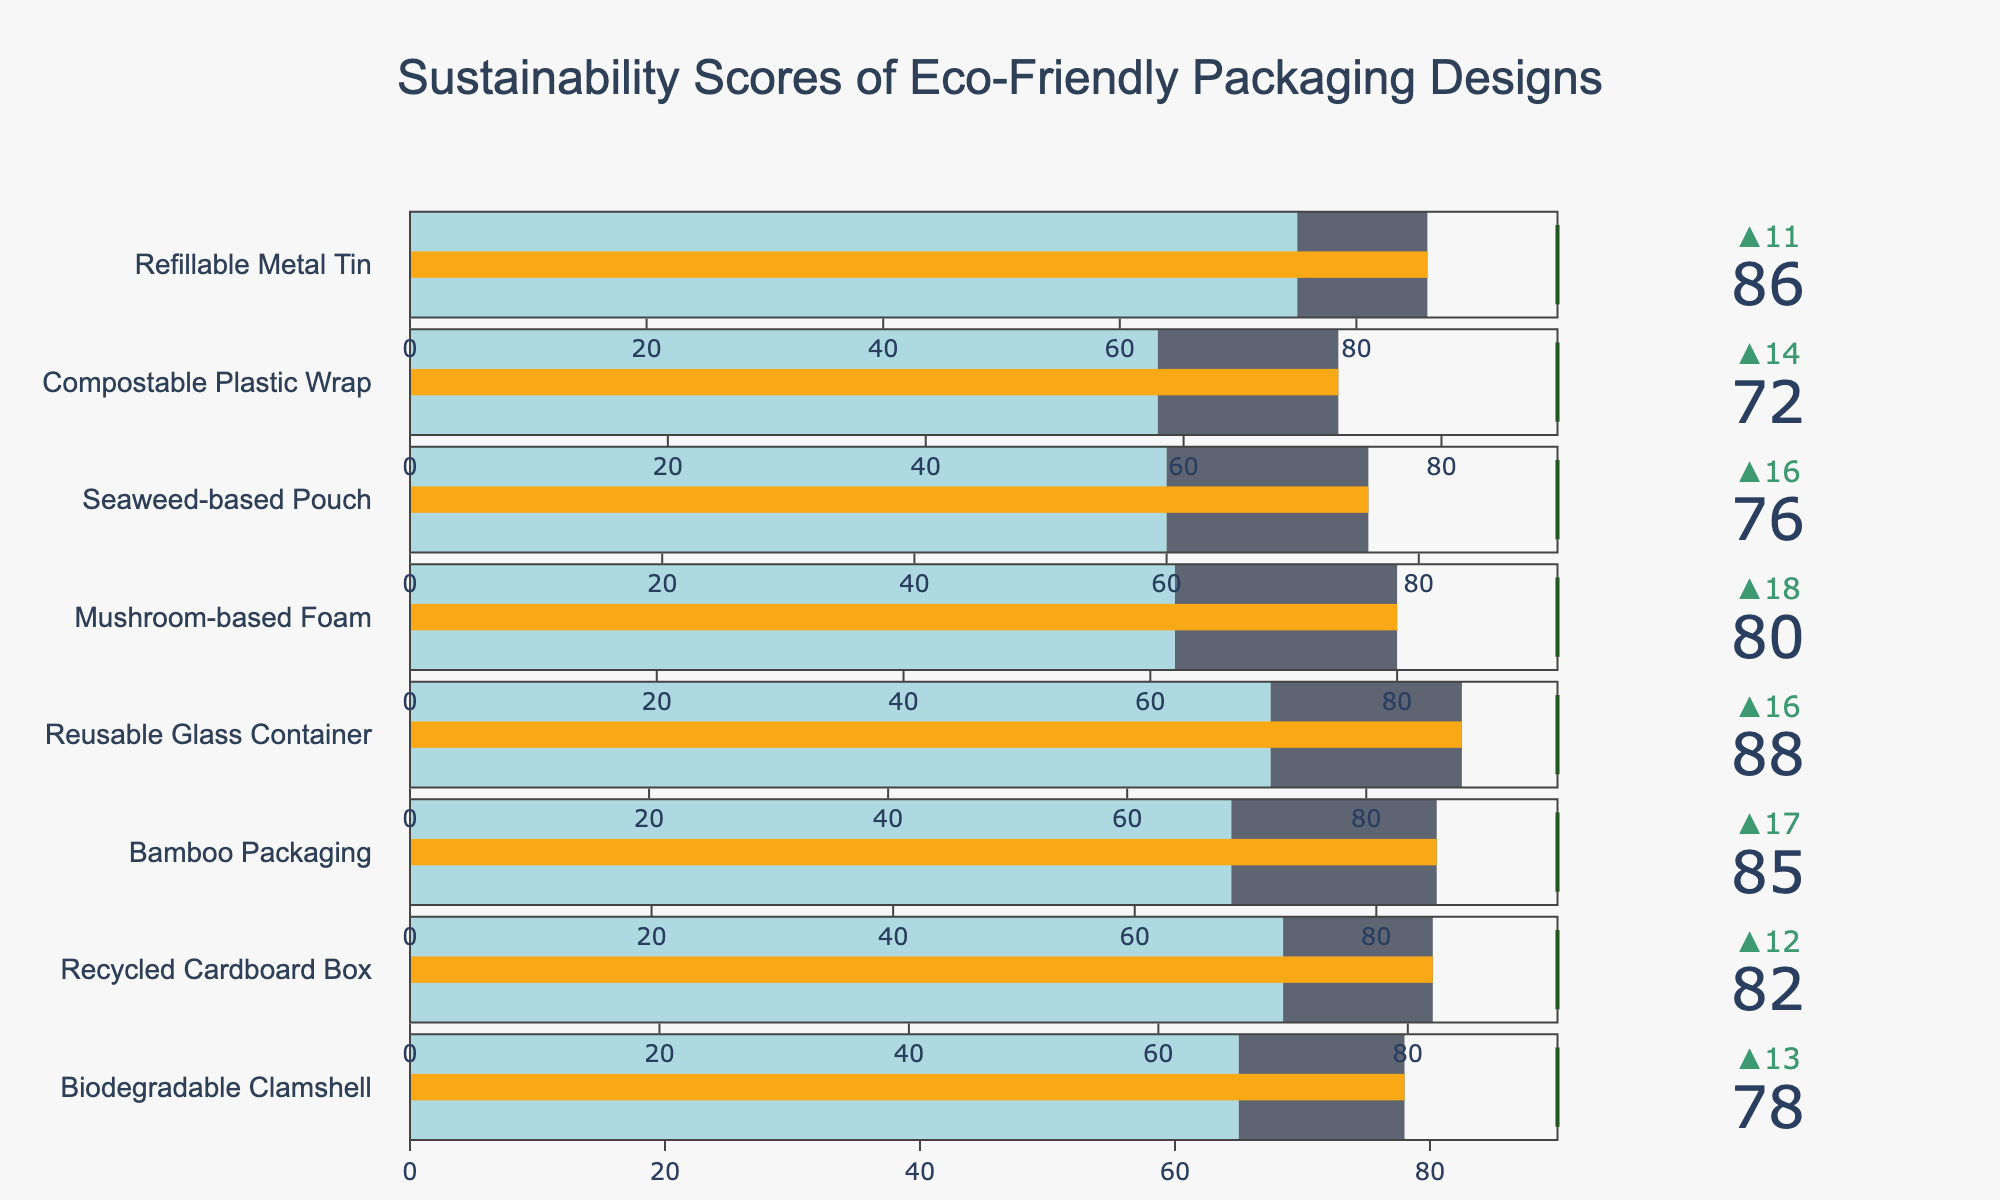What's the title of the figure? The title is displayed at the top center of the figure. It reads "Sustainability Scores of Eco-Friendly Packaging Designs."
Answer: Sustainability Scores of Eco-Friendly Packaging Designs How many packaging designs are compared in the figure? By counting the number of bullet charts in the figure, we see there are 8 packaging designs listed.
Answer: 8 Which eco-friendly packaging design has the highest sustainability score? The packaging design with the highest value in the figure is the "Reusable Glass Container" with a score of 88.
Answer: Reusable Glass Container What's the difference between the sustainability score of the Bamboo Packaging and the Industry Average for that product? The sustainability score for Bamboo Packaging is 85 and the Industry Average is 68. The difference is 85 - 68.
Answer: 17 Which product comes closest to its 'Best in Class' score? By examining the distance between the 'Sustainability Score' and 'Best in Class' values, the Refillable Metal Tin, with a score of 86 and a 'Best in Class' of 97, has the closest value, with a difference of 11.
Answer: Refillable Metal Tin Which product has the smallest improvement over the industry average? The smallest improvement is in the Compostable Plastic Wrap with a score of 72 and an Industry Average of 58, resulting in an improvement of 14.
Answer: Compostable Plastic Wrap What color represents the part of the gauge below the industry average? The color below the industry average in the gauge is light blue.
Answer: light blue How does the score for Mushroom-based Foam compare to that of Seaweed-based Pouch? Mushroom-based Foam has a sustainability score of 80, while Seaweed-based Pouch has a score of 76. Mushroom-based Foam has a higher score.
Answer: Mushroom-based Foam What is the median sustainability score of the eco-friendly packaging designs? To find the median, list the scores: 72, 76, 78, 80, 82, 85, 86, 88. The median is the average of the 4th and 5th values: (80 + 82) / 2 = 81.
Answer: 81 Which packaging design's 'Best in Class' score is the highest, and what is it? The Refillable Metal Tin has the highest 'Best in Class' score with a value of 97.
Answer: Refillable Metal Tin 